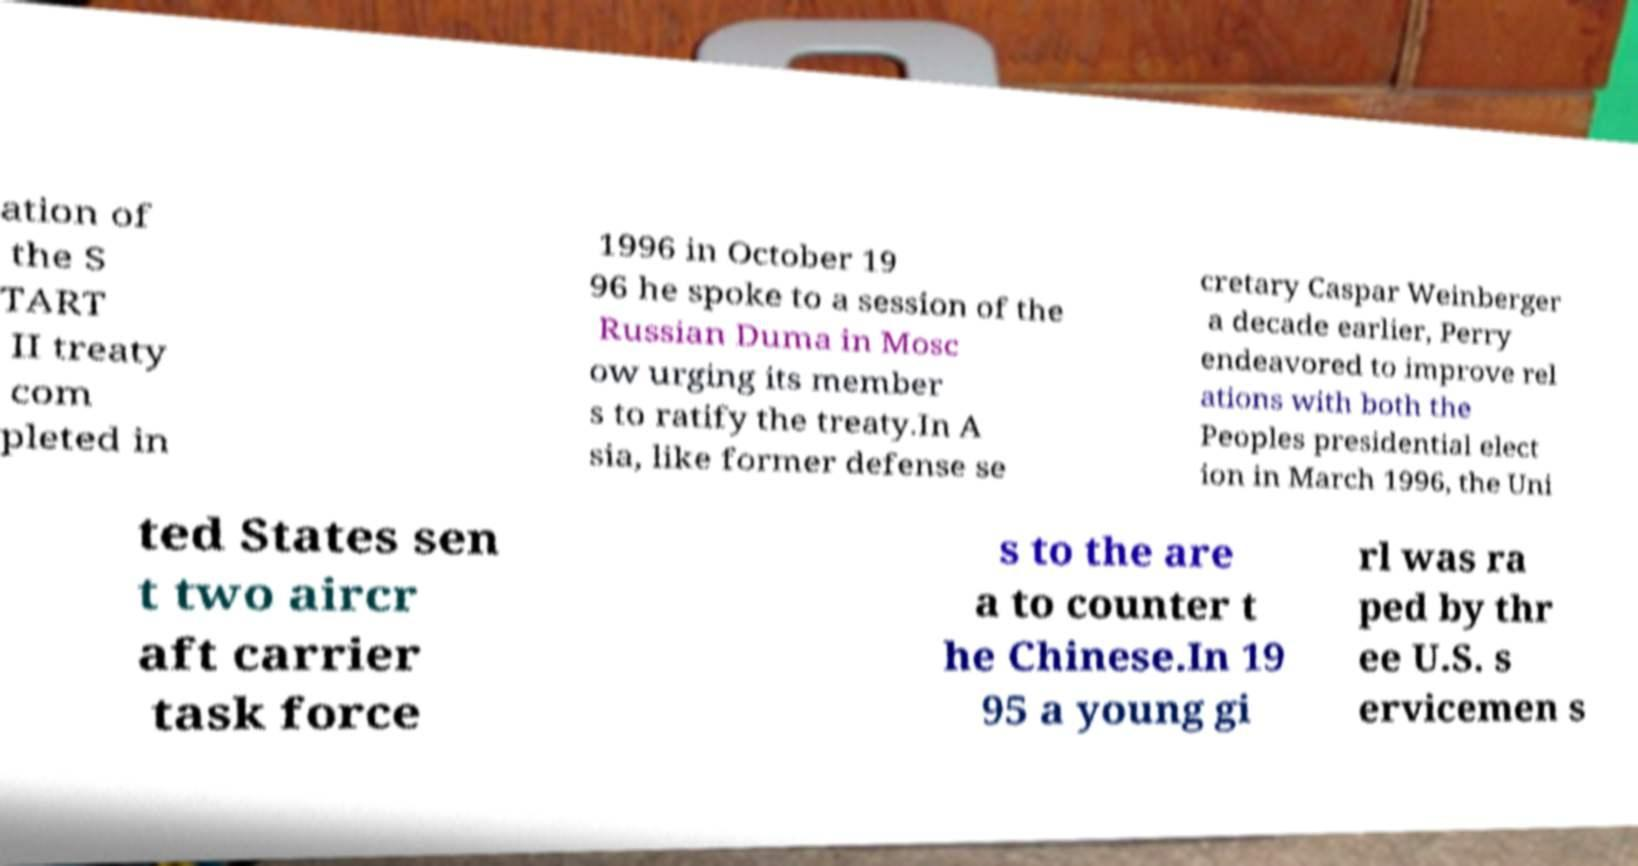What messages or text are displayed in this image? I need them in a readable, typed format. ation of the S TART II treaty com pleted in 1996 in October 19 96 he spoke to a session of the Russian Duma in Mosc ow urging its member s to ratify the treaty.In A sia, like former defense se cretary Caspar Weinberger a decade earlier, Perry endeavored to improve rel ations with both the Peoples presidential elect ion in March 1996, the Uni ted States sen t two aircr aft carrier task force s to the are a to counter t he Chinese.In 19 95 a young gi rl was ra ped by thr ee U.S. s ervicemen s 